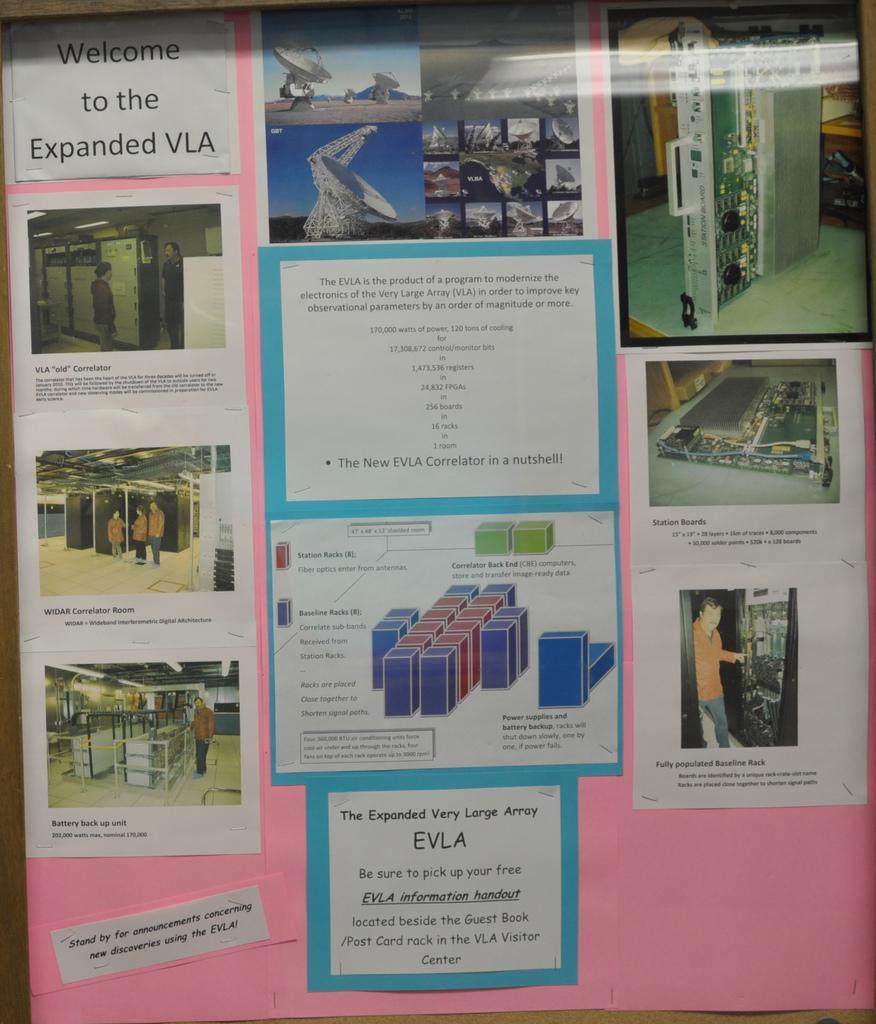Please provide a concise description of this image. In this picture we can see some posters on a pink chart. 